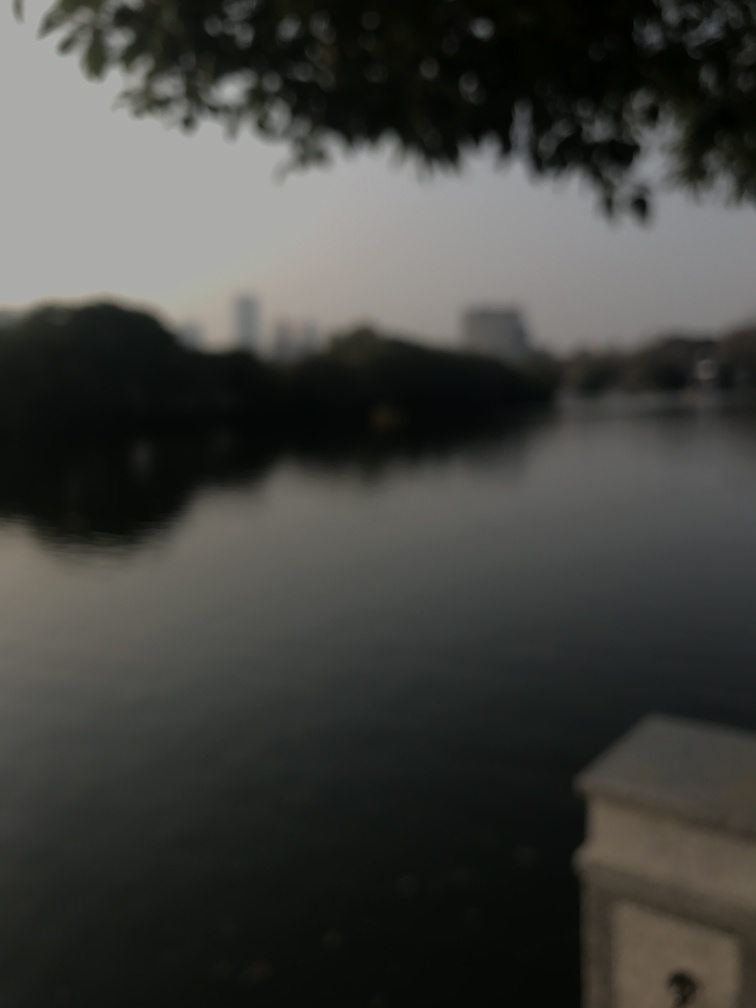What could be the reason for the blurriness of the image? The blurriness could result from several factors: a deliberate artistic choice to evoke a dreamlike quality, a camera lens focused on a different plane than the one captured, or even natural conditions such as fog. Additionally, it might have been taken from a moving vehicle or with an unsteady hand, resulting in a lack of sharpness. Could the blurriness serve an artistic purpose? Absolutely, the blurriness can serve an artistic purpose by softening the scene, encouraging viewers to focus on the emotional or atmospheric elements rather than precise details. It can also create a sense of mystery or nostalgia, as it leaves much to interpretation. 